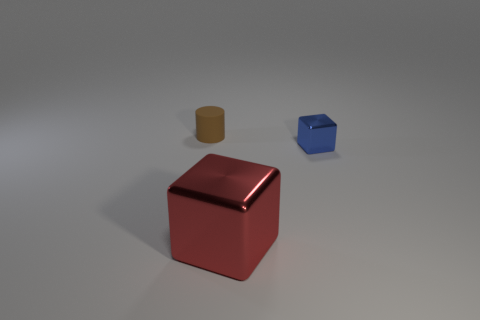Add 2 tiny brown things. How many objects exist? 5 Subtract all blue blocks. How many blocks are left? 1 Subtract all cubes. How many objects are left? 1 Add 1 large yellow cylinders. How many large yellow cylinders exist? 1 Subtract 0 cyan cylinders. How many objects are left? 3 Subtract 1 cylinders. How many cylinders are left? 0 Subtract all yellow cylinders. Subtract all purple spheres. How many cylinders are left? 1 Subtract all brown rubber spheres. Subtract all small brown rubber cylinders. How many objects are left? 2 Add 1 big metal blocks. How many big metal blocks are left? 2 